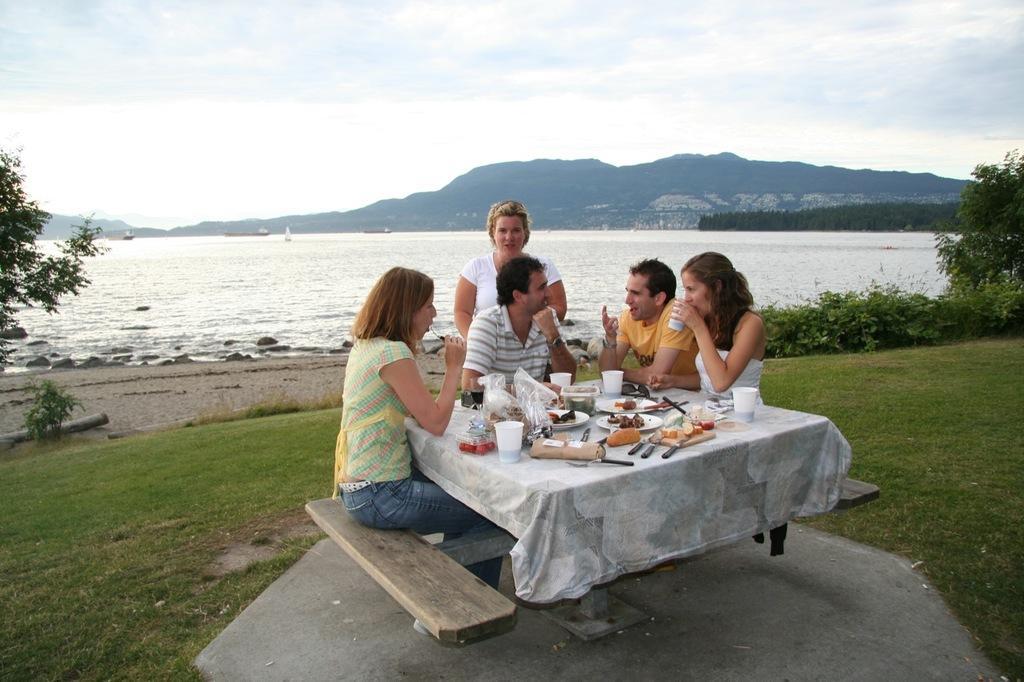Describe this image in one or two sentences. In the given image we can see there are five people four of them are sitting and one is standing. This is a bench, there is a table on the table we can see glass, knife, plate and food in a plate. There is a beach, hill, tree and a grass. 